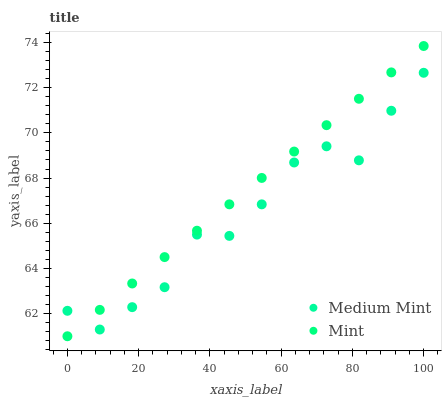Does Medium Mint have the minimum area under the curve?
Answer yes or no. Yes. Does Mint have the maximum area under the curve?
Answer yes or no. Yes. Does Mint have the minimum area under the curve?
Answer yes or no. No. Is Mint the smoothest?
Answer yes or no. Yes. Is Medium Mint the roughest?
Answer yes or no. Yes. Is Mint the roughest?
Answer yes or no. No. Does Mint have the lowest value?
Answer yes or no. Yes. Does Mint have the highest value?
Answer yes or no. Yes. Does Medium Mint intersect Mint?
Answer yes or no. Yes. Is Medium Mint less than Mint?
Answer yes or no. No. Is Medium Mint greater than Mint?
Answer yes or no. No. 